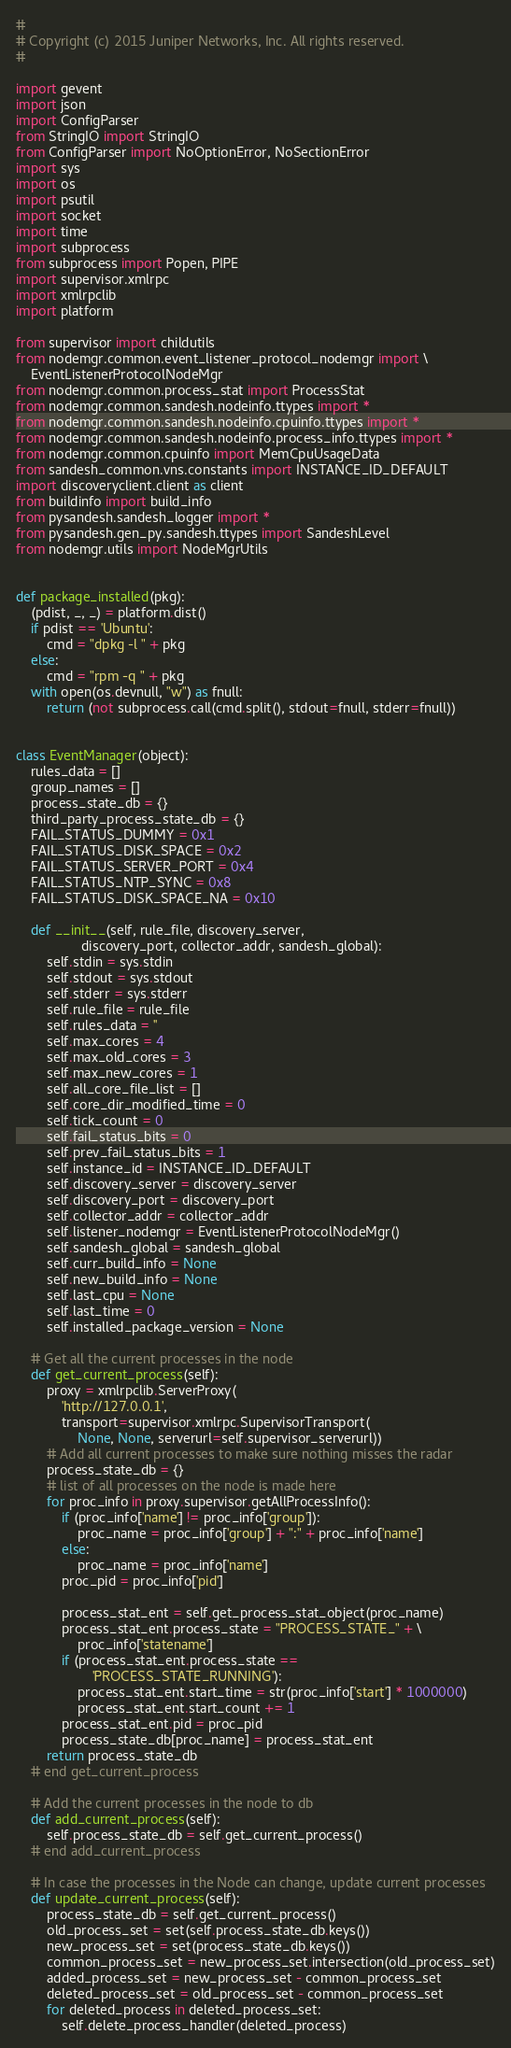<code> <loc_0><loc_0><loc_500><loc_500><_Python_>#
# Copyright (c) 2015 Juniper Networks, Inc. All rights reserved.
#

import gevent
import json
import ConfigParser
from StringIO import StringIO
from ConfigParser import NoOptionError, NoSectionError
import sys
import os
import psutil
import socket
import time
import subprocess
from subprocess import Popen, PIPE
import supervisor.xmlrpc
import xmlrpclib
import platform

from supervisor import childutils
from nodemgr.common.event_listener_protocol_nodemgr import \
    EventListenerProtocolNodeMgr
from nodemgr.common.process_stat import ProcessStat
from nodemgr.common.sandesh.nodeinfo.ttypes import *
from nodemgr.common.sandesh.nodeinfo.cpuinfo.ttypes import *
from nodemgr.common.sandesh.nodeinfo.process_info.ttypes import *
from nodemgr.common.cpuinfo import MemCpuUsageData
from sandesh_common.vns.constants import INSTANCE_ID_DEFAULT
import discoveryclient.client as client
from buildinfo import build_info
from pysandesh.sandesh_logger import *
from pysandesh.gen_py.sandesh.ttypes import SandeshLevel
from nodemgr.utils import NodeMgrUtils


def package_installed(pkg):
    (pdist, _, _) = platform.dist()
    if pdist == 'Ubuntu':
        cmd = "dpkg -l " + pkg
    else:
        cmd = "rpm -q " + pkg
    with open(os.devnull, "w") as fnull:
        return (not subprocess.call(cmd.split(), stdout=fnull, stderr=fnull))


class EventManager(object):
    rules_data = []
    group_names = []
    process_state_db = {}
    third_party_process_state_db = {}
    FAIL_STATUS_DUMMY = 0x1
    FAIL_STATUS_DISK_SPACE = 0x2
    FAIL_STATUS_SERVER_PORT = 0x4
    FAIL_STATUS_NTP_SYNC = 0x8
    FAIL_STATUS_DISK_SPACE_NA = 0x10

    def __init__(self, rule_file, discovery_server,
                 discovery_port, collector_addr, sandesh_global):
        self.stdin = sys.stdin
        self.stdout = sys.stdout
        self.stderr = sys.stderr
        self.rule_file = rule_file
        self.rules_data = ''
        self.max_cores = 4
        self.max_old_cores = 3
        self.max_new_cores = 1
        self.all_core_file_list = []
        self.core_dir_modified_time = 0
        self.tick_count = 0
        self.fail_status_bits = 0
        self.prev_fail_status_bits = 1
        self.instance_id = INSTANCE_ID_DEFAULT
        self.discovery_server = discovery_server
        self.discovery_port = discovery_port
        self.collector_addr = collector_addr
        self.listener_nodemgr = EventListenerProtocolNodeMgr()
        self.sandesh_global = sandesh_global
        self.curr_build_info = None
        self.new_build_info = None
        self.last_cpu = None
        self.last_time = 0
        self.installed_package_version = None

    # Get all the current processes in the node
    def get_current_process(self):
        proxy = xmlrpclib.ServerProxy(
            'http://127.0.0.1',
            transport=supervisor.xmlrpc.SupervisorTransport(
                None, None, serverurl=self.supervisor_serverurl))
        # Add all current processes to make sure nothing misses the radar
        process_state_db = {}
        # list of all processes on the node is made here
        for proc_info in proxy.supervisor.getAllProcessInfo():
            if (proc_info['name'] != proc_info['group']):
                proc_name = proc_info['group'] + ":" + proc_info['name']
            else:
                proc_name = proc_info['name']
            proc_pid = proc_info['pid']

            process_stat_ent = self.get_process_stat_object(proc_name)
            process_stat_ent.process_state = "PROCESS_STATE_" + \
                proc_info['statename']
            if (process_stat_ent.process_state ==
                    'PROCESS_STATE_RUNNING'):
                process_stat_ent.start_time = str(proc_info['start'] * 1000000)
                process_stat_ent.start_count += 1
            process_stat_ent.pid = proc_pid
            process_state_db[proc_name] = process_stat_ent
        return process_state_db
    # end get_current_process

    # Add the current processes in the node to db
    def add_current_process(self):
        self.process_state_db = self.get_current_process()
    # end add_current_process

    # In case the processes in the Node can change, update current processes
    def update_current_process(self):
        process_state_db = self.get_current_process()
        old_process_set = set(self.process_state_db.keys())
        new_process_set = set(process_state_db.keys())
        common_process_set = new_process_set.intersection(old_process_set)
        added_process_set = new_process_set - common_process_set
        deleted_process_set = old_process_set - common_process_set
        for deleted_process in deleted_process_set:
            self.delete_process_handler(deleted_process)</code> 